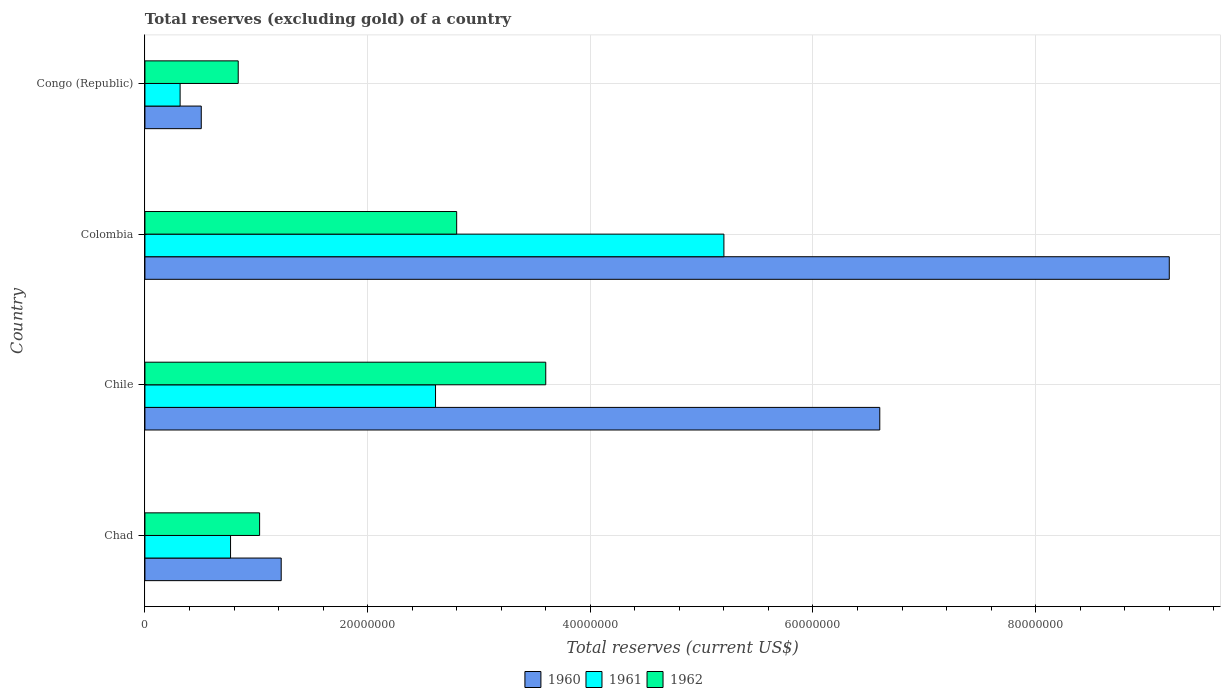How many different coloured bars are there?
Give a very brief answer. 3. How many groups of bars are there?
Ensure brevity in your answer.  4. How many bars are there on the 4th tick from the bottom?
Keep it short and to the point. 3. What is the label of the 1st group of bars from the top?
Your answer should be compact. Congo (Republic). What is the total reserves (excluding gold) in 1961 in Chile?
Make the answer very short. 2.61e+07. Across all countries, what is the maximum total reserves (excluding gold) in 1960?
Your response must be concise. 9.20e+07. Across all countries, what is the minimum total reserves (excluding gold) in 1960?
Provide a short and direct response. 5.06e+06. In which country was the total reserves (excluding gold) in 1960 maximum?
Ensure brevity in your answer.  Colombia. In which country was the total reserves (excluding gold) in 1961 minimum?
Keep it short and to the point. Congo (Republic). What is the total total reserves (excluding gold) in 1960 in the graph?
Offer a terse response. 1.75e+08. What is the difference between the total reserves (excluding gold) in 1962 in Colombia and that in Congo (Republic)?
Ensure brevity in your answer.  1.96e+07. What is the difference between the total reserves (excluding gold) in 1961 in Congo (Republic) and the total reserves (excluding gold) in 1962 in Chile?
Offer a terse response. -3.28e+07. What is the average total reserves (excluding gold) in 1960 per country?
Give a very brief answer. 4.38e+07. What is the difference between the total reserves (excluding gold) in 1962 and total reserves (excluding gold) in 1961 in Chad?
Offer a terse response. 2.61e+06. What is the ratio of the total reserves (excluding gold) in 1962 in Chile to that in Congo (Republic)?
Ensure brevity in your answer.  4.3. What is the difference between the highest and the second highest total reserves (excluding gold) in 1960?
Make the answer very short. 2.60e+07. What is the difference between the highest and the lowest total reserves (excluding gold) in 1962?
Offer a terse response. 2.76e+07. What does the 1st bar from the bottom in Colombia represents?
Make the answer very short. 1960. How many countries are there in the graph?
Make the answer very short. 4. What is the difference between two consecutive major ticks on the X-axis?
Your answer should be very brief. 2.00e+07. Are the values on the major ticks of X-axis written in scientific E-notation?
Give a very brief answer. No. Does the graph contain grids?
Provide a short and direct response. Yes. Where does the legend appear in the graph?
Your answer should be very brief. Bottom center. What is the title of the graph?
Your answer should be very brief. Total reserves (excluding gold) of a country. What is the label or title of the X-axis?
Provide a succinct answer. Total reserves (current US$). What is the Total reserves (current US$) of 1960 in Chad?
Your response must be concise. 1.22e+07. What is the Total reserves (current US$) of 1961 in Chad?
Provide a short and direct response. 7.69e+06. What is the Total reserves (current US$) of 1962 in Chad?
Offer a very short reply. 1.03e+07. What is the Total reserves (current US$) in 1960 in Chile?
Offer a very short reply. 6.60e+07. What is the Total reserves (current US$) in 1961 in Chile?
Your answer should be compact. 2.61e+07. What is the Total reserves (current US$) of 1962 in Chile?
Your answer should be very brief. 3.60e+07. What is the Total reserves (current US$) of 1960 in Colombia?
Make the answer very short. 9.20e+07. What is the Total reserves (current US$) of 1961 in Colombia?
Give a very brief answer. 5.20e+07. What is the Total reserves (current US$) of 1962 in Colombia?
Your answer should be compact. 2.80e+07. What is the Total reserves (current US$) of 1960 in Congo (Republic)?
Offer a terse response. 5.06e+06. What is the Total reserves (current US$) in 1961 in Congo (Republic)?
Your answer should be very brief. 3.16e+06. What is the Total reserves (current US$) of 1962 in Congo (Republic)?
Offer a very short reply. 8.38e+06. Across all countries, what is the maximum Total reserves (current US$) of 1960?
Make the answer very short. 9.20e+07. Across all countries, what is the maximum Total reserves (current US$) in 1961?
Provide a short and direct response. 5.20e+07. Across all countries, what is the maximum Total reserves (current US$) of 1962?
Give a very brief answer. 3.60e+07. Across all countries, what is the minimum Total reserves (current US$) of 1960?
Offer a very short reply. 5.06e+06. Across all countries, what is the minimum Total reserves (current US$) in 1961?
Ensure brevity in your answer.  3.16e+06. Across all countries, what is the minimum Total reserves (current US$) of 1962?
Ensure brevity in your answer.  8.38e+06. What is the total Total reserves (current US$) in 1960 in the graph?
Make the answer very short. 1.75e+08. What is the total Total reserves (current US$) of 1961 in the graph?
Your response must be concise. 8.90e+07. What is the total Total reserves (current US$) of 1962 in the graph?
Give a very brief answer. 8.27e+07. What is the difference between the Total reserves (current US$) in 1960 in Chad and that in Chile?
Make the answer very short. -5.38e+07. What is the difference between the Total reserves (current US$) of 1961 in Chad and that in Chile?
Make the answer very short. -1.84e+07. What is the difference between the Total reserves (current US$) in 1962 in Chad and that in Chile?
Provide a short and direct response. -2.57e+07. What is the difference between the Total reserves (current US$) of 1960 in Chad and that in Colombia?
Provide a succinct answer. -7.98e+07. What is the difference between the Total reserves (current US$) of 1961 in Chad and that in Colombia?
Ensure brevity in your answer.  -4.43e+07. What is the difference between the Total reserves (current US$) in 1962 in Chad and that in Colombia?
Your answer should be compact. -1.77e+07. What is the difference between the Total reserves (current US$) in 1960 in Chad and that in Congo (Republic)?
Provide a short and direct response. 7.18e+06. What is the difference between the Total reserves (current US$) in 1961 in Chad and that in Congo (Republic)?
Provide a short and direct response. 4.53e+06. What is the difference between the Total reserves (current US$) in 1962 in Chad and that in Congo (Republic)?
Your answer should be compact. 1.92e+06. What is the difference between the Total reserves (current US$) in 1960 in Chile and that in Colombia?
Keep it short and to the point. -2.60e+07. What is the difference between the Total reserves (current US$) of 1961 in Chile and that in Colombia?
Your answer should be compact. -2.59e+07. What is the difference between the Total reserves (current US$) in 1962 in Chile and that in Colombia?
Offer a terse response. 8.00e+06. What is the difference between the Total reserves (current US$) in 1960 in Chile and that in Congo (Republic)?
Ensure brevity in your answer.  6.09e+07. What is the difference between the Total reserves (current US$) in 1961 in Chile and that in Congo (Republic)?
Give a very brief answer. 2.29e+07. What is the difference between the Total reserves (current US$) in 1962 in Chile and that in Congo (Republic)?
Offer a very short reply. 2.76e+07. What is the difference between the Total reserves (current US$) in 1960 in Colombia and that in Congo (Republic)?
Keep it short and to the point. 8.69e+07. What is the difference between the Total reserves (current US$) of 1961 in Colombia and that in Congo (Republic)?
Offer a terse response. 4.88e+07. What is the difference between the Total reserves (current US$) in 1962 in Colombia and that in Congo (Republic)?
Provide a succinct answer. 1.96e+07. What is the difference between the Total reserves (current US$) in 1960 in Chad and the Total reserves (current US$) in 1961 in Chile?
Offer a terse response. -1.39e+07. What is the difference between the Total reserves (current US$) in 1960 in Chad and the Total reserves (current US$) in 1962 in Chile?
Your answer should be very brief. -2.38e+07. What is the difference between the Total reserves (current US$) of 1961 in Chad and the Total reserves (current US$) of 1962 in Chile?
Make the answer very short. -2.83e+07. What is the difference between the Total reserves (current US$) in 1960 in Chad and the Total reserves (current US$) in 1961 in Colombia?
Offer a very short reply. -3.98e+07. What is the difference between the Total reserves (current US$) in 1960 in Chad and the Total reserves (current US$) in 1962 in Colombia?
Your answer should be compact. -1.58e+07. What is the difference between the Total reserves (current US$) in 1961 in Chad and the Total reserves (current US$) in 1962 in Colombia?
Your answer should be compact. -2.03e+07. What is the difference between the Total reserves (current US$) of 1960 in Chad and the Total reserves (current US$) of 1961 in Congo (Republic)?
Ensure brevity in your answer.  9.08e+06. What is the difference between the Total reserves (current US$) in 1960 in Chad and the Total reserves (current US$) in 1962 in Congo (Republic)?
Make the answer very short. 3.86e+06. What is the difference between the Total reserves (current US$) in 1961 in Chad and the Total reserves (current US$) in 1962 in Congo (Republic)?
Ensure brevity in your answer.  -6.90e+05. What is the difference between the Total reserves (current US$) in 1960 in Chile and the Total reserves (current US$) in 1961 in Colombia?
Make the answer very short. 1.40e+07. What is the difference between the Total reserves (current US$) in 1960 in Chile and the Total reserves (current US$) in 1962 in Colombia?
Make the answer very short. 3.80e+07. What is the difference between the Total reserves (current US$) in 1961 in Chile and the Total reserves (current US$) in 1962 in Colombia?
Give a very brief answer. -1.90e+06. What is the difference between the Total reserves (current US$) of 1960 in Chile and the Total reserves (current US$) of 1961 in Congo (Republic)?
Provide a short and direct response. 6.28e+07. What is the difference between the Total reserves (current US$) in 1960 in Chile and the Total reserves (current US$) in 1962 in Congo (Republic)?
Ensure brevity in your answer.  5.76e+07. What is the difference between the Total reserves (current US$) in 1961 in Chile and the Total reserves (current US$) in 1962 in Congo (Republic)?
Your response must be concise. 1.77e+07. What is the difference between the Total reserves (current US$) of 1960 in Colombia and the Total reserves (current US$) of 1961 in Congo (Republic)?
Keep it short and to the point. 8.88e+07. What is the difference between the Total reserves (current US$) of 1960 in Colombia and the Total reserves (current US$) of 1962 in Congo (Republic)?
Provide a succinct answer. 8.36e+07. What is the difference between the Total reserves (current US$) of 1961 in Colombia and the Total reserves (current US$) of 1962 in Congo (Republic)?
Provide a succinct answer. 4.36e+07. What is the average Total reserves (current US$) of 1960 per country?
Offer a terse response. 4.38e+07. What is the average Total reserves (current US$) in 1961 per country?
Your response must be concise. 2.22e+07. What is the average Total reserves (current US$) of 1962 per country?
Ensure brevity in your answer.  2.07e+07. What is the difference between the Total reserves (current US$) in 1960 and Total reserves (current US$) in 1961 in Chad?
Offer a very short reply. 4.55e+06. What is the difference between the Total reserves (current US$) of 1960 and Total reserves (current US$) of 1962 in Chad?
Your answer should be compact. 1.94e+06. What is the difference between the Total reserves (current US$) in 1961 and Total reserves (current US$) in 1962 in Chad?
Ensure brevity in your answer.  -2.61e+06. What is the difference between the Total reserves (current US$) of 1960 and Total reserves (current US$) of 1961 in Chile?
Ensure brevity in your answer.  3.99e+07. What is the difference between the Total reserves (current US$) in 1960 and Total reserves (current US$) in 1962 in Chile?
Give a very brief answer. 3.00e+07. What is the difference between the Total reserves (current US$) of 1961 and Total reserves (current US$) of 1962 in Chile?
Provide a succinct answer. -9.90e+06. What is the difference between the Total reserves (current US$) of 1960 and Total reserves (current US$) of 1961 in Colombia?
Provide a short and direct response. 4.00e+07. What is the difference between the Total reserves (current US$) of 1960 and Total reserves (current US$) of 1962 in Colombia?
Ensure brevity in your answer.  6.40e+07. What is the difference between the Total reserves (current US$) in 1961 and Total reserves (current US$) in 1962 in Colombia?
Your answer should be very brief. 2.40e+07. What is the difference between the Total reserves (current US$) in 1960 and Total reserves (current US$) in 1961 in Congo (Republic)?
Provide a short and direct response. 1.90e+06. What is the difference between the Total reserves (current US$) in 1960 and Total reserves (current US$) in 1962 in Congo (Republic)?
Offer a very short reply. -3.32e+06. What is the difference between the Total reserves (current US$) of 1961 and Total reserves (current US$) of 1962 in Congo (Republic)?
Make the answer very short. -5.22e+06. What is the ratio of the Total reserves (current US$) in 1960 in Chad to that in Chile?
Give a very brief answer. 0.19. What is the ratio of the Total reserves (current US$) in 1961 in Chad to that in Chile?
Offer a terse response. 0.29. What is the ratio of the Total reserves (current US$) in 1962 in Chad to that in Chile?
Make the answer very short. 0.29. What is the ratio of the Total reserves (current US$) of 1960 in Chad to that in Colombia?
Keep it short and to the point. 0.13. What is the ratio of the Total reserves (current US$) of 1961 in Chad to that in Colombia?
Offer a very short reply. 0.15. What is the ratio of the Total reserves (current US$) of 1962 in Chad to that in Colombia?
Your answer should be compact. 0.37. What is the ratio of the Total reserves (current US$) of 1960 in Chad to that in Congo (Republic)?
Your answer should be very brief. 2.42. What is the ratio of the Total reserves (current US$) of 1961 in Chad to that in Congo (Republic)?
Provide a short and direct response. 2.43. What is the ratio of the Total reserves (current US$) in 1962 in Chad to that in Congo (Republic)?
Keep it short and to the point. 1.23. What is the ratio of the Total reserves (current US$) in 1960 in Chile to that in Colombia?
Your response must be concise. 0.72. What is the ratio of the Total reserves (current US$) in 1961 in Chile to that in Colombia?
Your answer should be compact. 0.5. What is the ratio of the Total reserves (current US$) in 1962 in Chile to that in Colombia?
Provide a short and direct response. 1.29. What is the ratio of the Total reserves (current US$) of 1960 in Chile to that in Congo (Republic)?
Provide a succinct answer. 13.04. What is the ratio of the Total reserves (current US$) of 1961 in Chile to that in Congo (Republic)?
Provide a succinct answer. 8.26. What is the ratio of the Total reserves (current US$) in 1962 in Chile to that in Congo (Republic)?
Provide a succinct answer. 4.3. What is the ratio of the Total reserves (current US$) of 1960 in Colombia to that in Congo (Republic)?
Your answer should be compact. 18.18. What is the ratio of the Total reserves (current US$) of 1961 in Colombia to that in Congo (Republic)?
Provide a short and direct response. 16.46. What is the ratio of the Total reserves (current US$) of 1962 in Colombia to that in Congo (Republic)?
Provide a short and direct response. 3.34. What is the difference between the highest and the second highest Total reserves (current US$) in 1960?
Offer a terse response. 2.60e+07. What is the difference between the highest and the second highest Total reserves (current US$) of 1961?
Your response must be concise. 2.59e+07. What is the difference between the highest and the lowest Total reserves (current US$) of 1960?
Keep it short and to the point. 8.69e+07. What is the difference between the highest and the lowest Total reserves (current US$) in 1961?
Offer a terse response. 4.88e+07. What is the difference between the highest and the lowest Total reserves (current US$) of 1962?
Give a very brief answer. 2.76e+07. 